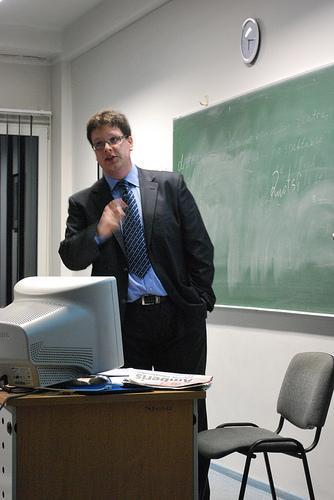How many chairs are there?
Give a very brief answer. 1. 